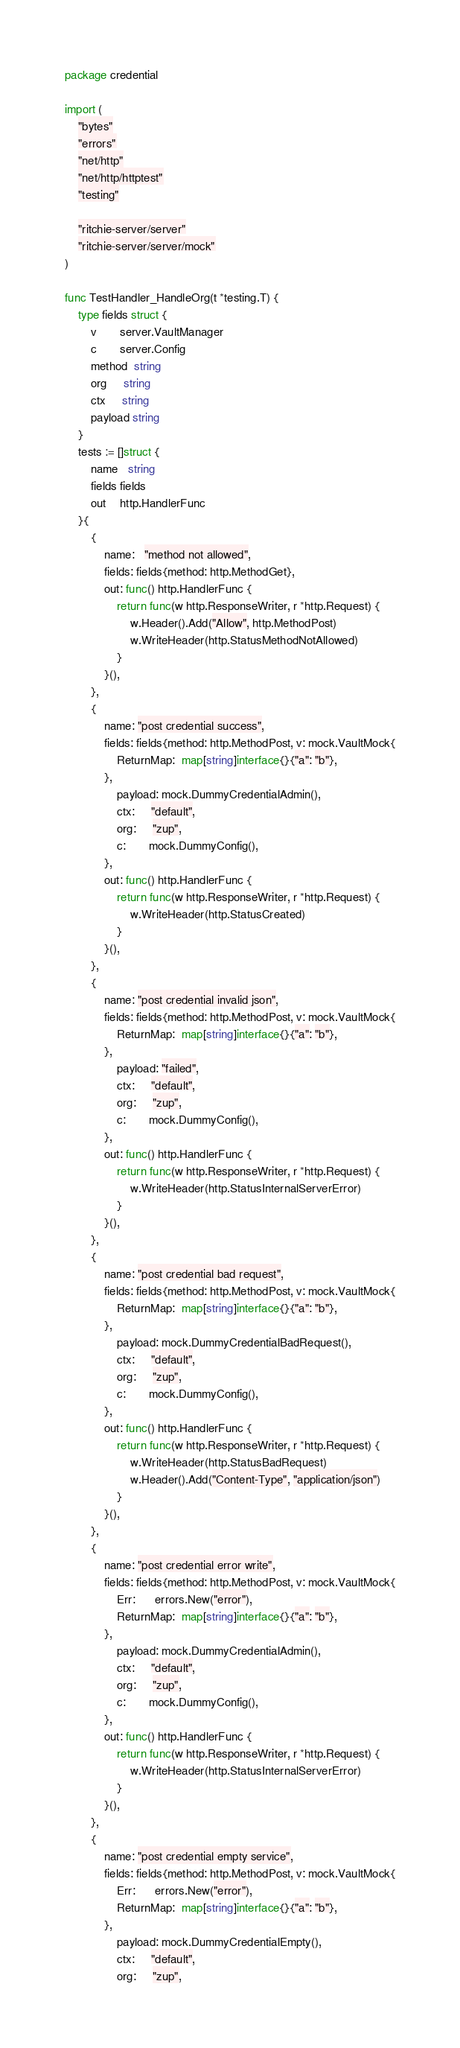Convert code to text. <code><loc_0><loc_0><loc_500><loc_500><_Go_>package credential

import (
	"bytes"
	"errors"
	"net/http"
	"net/http/httptest"
	"testing"

	"ritchie-server/server"
	"ritchie-server/server/mock"
)

func TestHandler_HandleOrg(t *testing.T) {
	type fields struct {
		v       server.VaultManager
		c       server.Config
		method  string
		org     string
		ctx     string
		payload string
	}
	tests := []struct {
		name   string
		fields fields
		out    http.HandlerFunc
	}{
		{
			name:   "method not allowed",
			fields: fields{method: http.MethodGet},
			out: func() http.HandlerFunc {
				return func(w http.ResponseWriter, r *http.Request) {
					w.Header().Add("Allow", http.MethodPost)
					w.WriteHeader(http.StatusMethodNotAllowed)
				}
			}(),
		},
		{
			name: "post credential success",
			fields: fields{method: http.MethodPost, v: mock.VaultMock{
				ReturnMap:  map[string]interface{}{"a": "b"},
			},
				payload: mock.DummyCredentialAdmin(),
				ctx:     "default",
				org:     "zup",
				c:       mock.DummyConfig(),
			},
			out: func() http.HandlerFunc {
				return func(w http.ResponseWriter, r *http.Request) {
					w.WriteHeader(http.StatusCreated)
				}
			}(),
		},
		{
			name: "post credential invalid json",
			fields: fields{method: http.MethodPost, v: mock.VaultMock{
				ReturnMap:  map[string]interface{}{"a": "b"},
			},
				payload: "failed",
				ctx:     "default",
				org:     "zup",
				c:       mock.DummyConfig(),
			},
			out: func() http.HandlerFunc {
				return func(w http.ResponseWriter, r *http.Request) {
					w.WriteHeader(http.StatusInternalServerError)
				}
			}(),
		},
		{
			name: "post credential bad request",
			fields: fields{method: http.MethodPost, v: mock.VaultMock{
				ReturnMap:  map[string]interface{}{"a": "b"},
			},
				payload: mock.DummyCredentialBadRequest(),
				ctx:     "default",
				org:     "zup",
				c:       mock.DummyConfig(),
			},
			out: func() http.HandlerFunc {
				return func(w http.ResponseWriter, r *http.Request) {
					w.WriteHeader(http.StatusBadRequest)
					w.Header().Add("Content-Type", "application/json")
				}
			}(),
		},
		{
			name: "post credential error write",
			fields: fields{method: http.MethodPost, v: mock.VaultMock{
				Err:      errors.New("error"),
				ReturnMap:  map[string]interface{}{"a": "b"},
			},
				payload: mock.DummyCredentialAdmin(),
				ctx:     "default",
				org:     "zup",
				c:       mock.DummyConfig(),
			},
			out: func() http.HandlerFunc {
				return func(w http.ResponseWriter, r *http.Request) {
					w.WriteHeader(http.StatusInternalServerError)
				}
			}(),
		},
		{
			name: "post credential empty service",
			fields: fields{method: http.MethodPost, v: mock.VaultMock{
				Err:      errors.New("error"),
				ReturnMap:  map[string]interface{}{"a": "b"},
			},
				payload: mock.DummyCredentialEmpty(),
				ctx:     "default",
				org:     "zup",</code> 